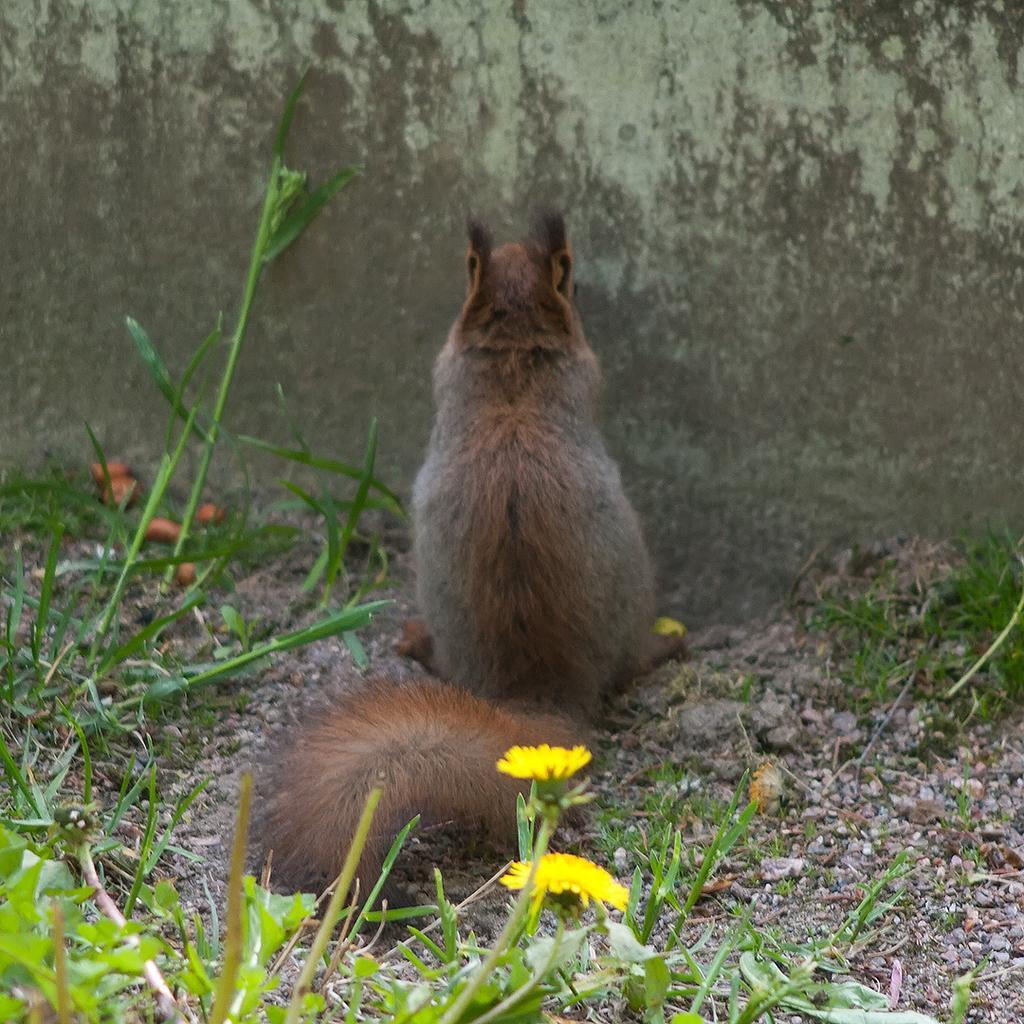How would you summarize this image in a sentence or two? In this image there is an animal on the ground, there are plants, there are flowers, there are plants truncated towards the right of the image, there are plants truncated towards the bottom of the image, there are plants truncated towards the left of the image, there is a wall. 